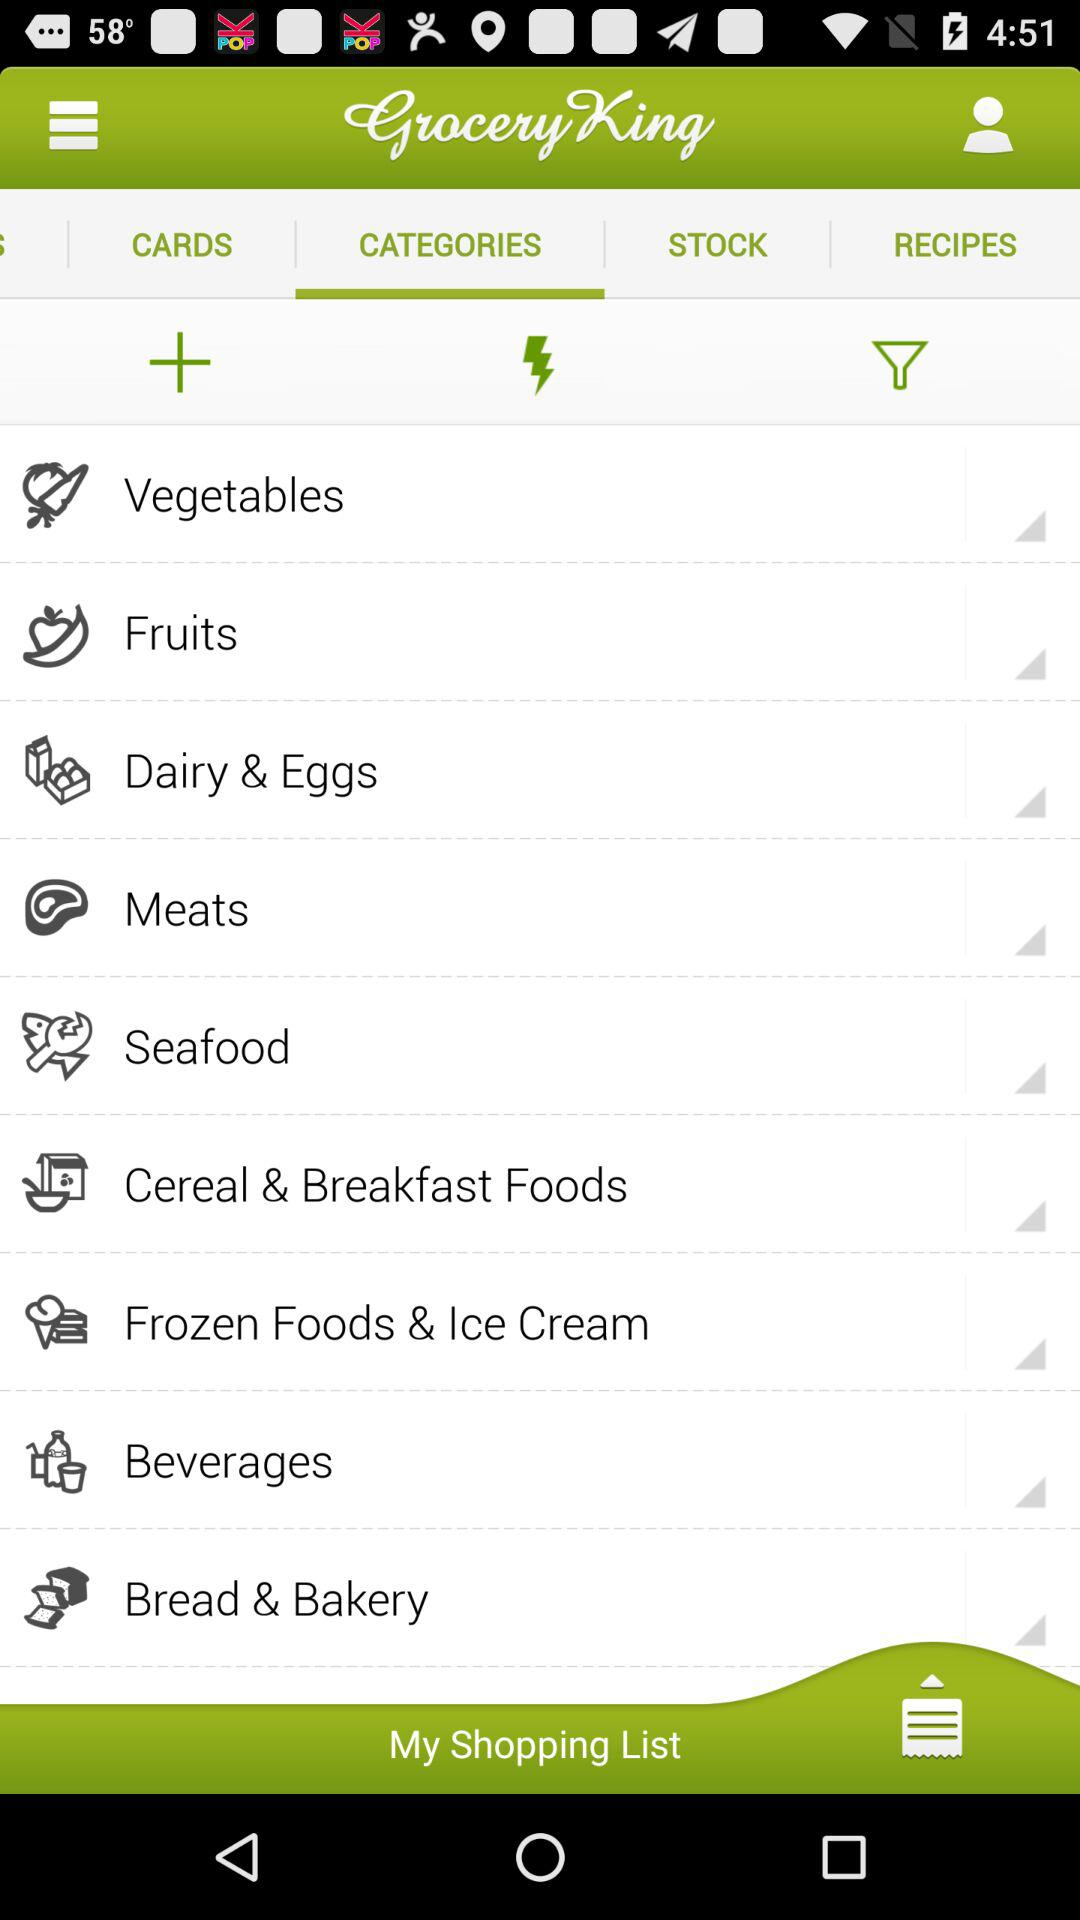Which tab is selected? The selected tab is "CATEGORIES". 